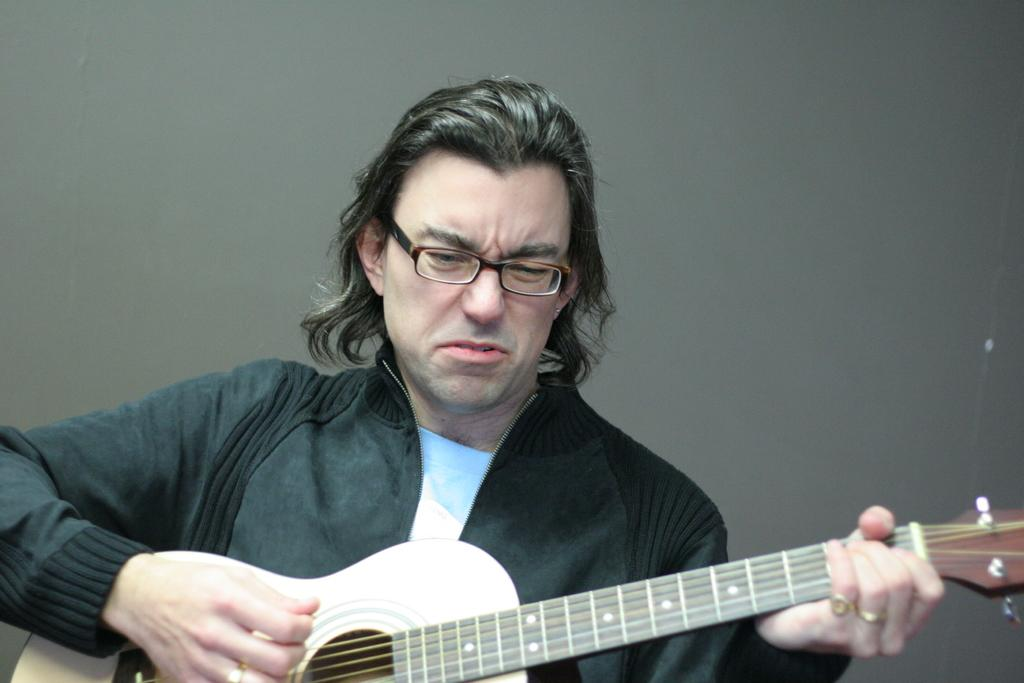Who is present in the image? There is a man in the image. What is the man holding in the image? The man is holding a guitar. How many clocks can be seen in the image? There are no clocks visible in the image. What is the reason for the man holding the guitar in the image? The image does not provide any information about the reason for the man holding the guitar. 